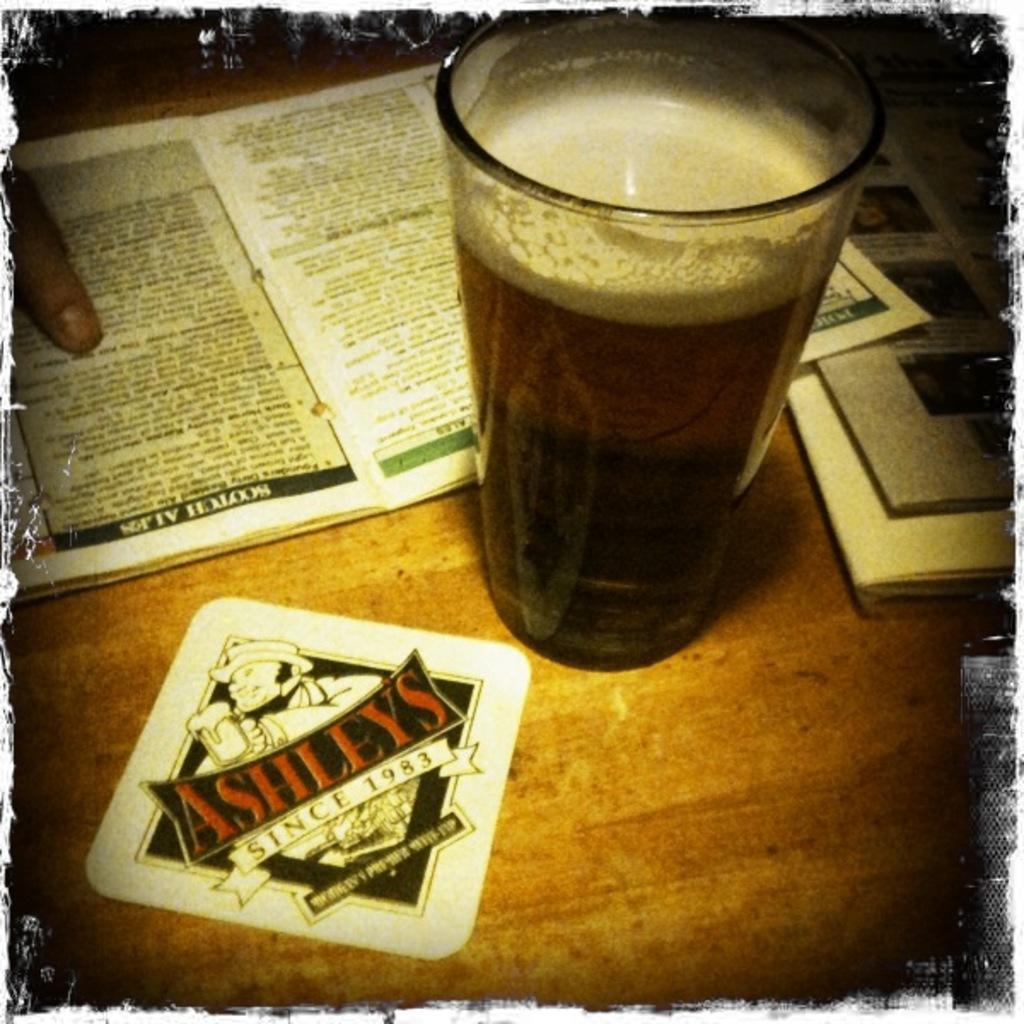When was ashleys founded?
Offer a terse response. 1983. What is the name on the coaster?
Offer a terse response. Ashleys. 